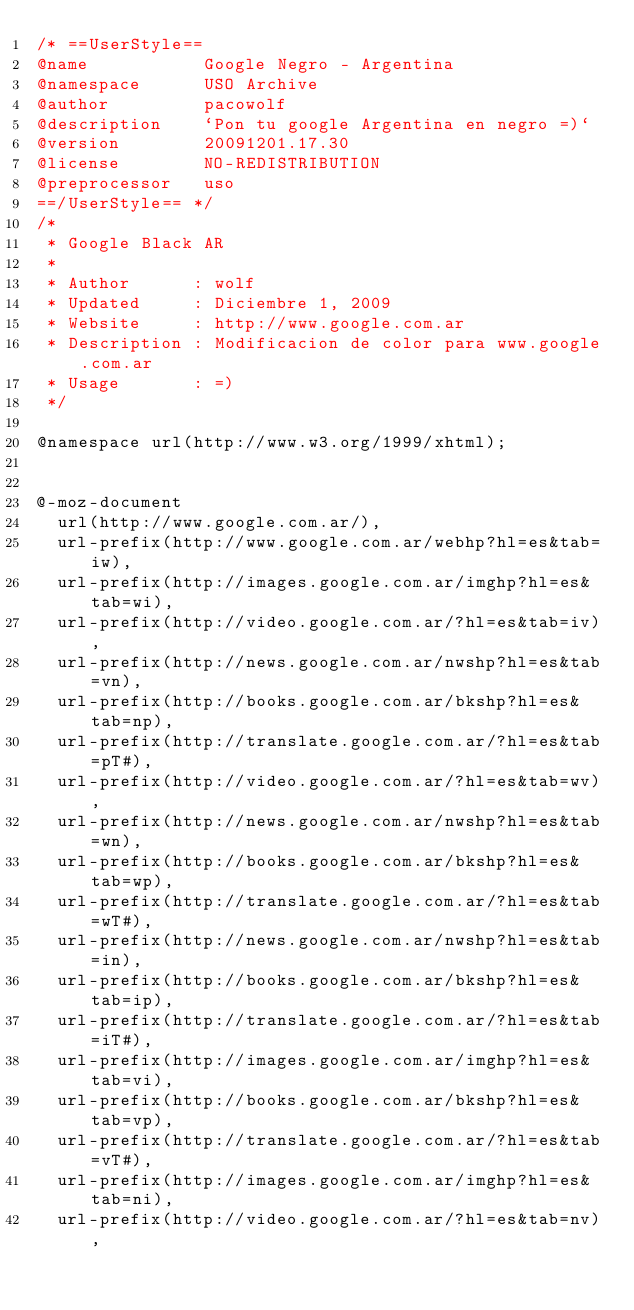Convert code to text. <code><loc_0><loc_0><loc_500><loc_500><_CSS_>/* ==UserStyle==
@name           Google Negro - Argentina
@namespace      USO Archive
@author         pacowolf
@description    `Pon tu google Argentina en negro =)`
@version        20091201.17.30
@license        NO-REDISTRIBUTION
@preprocessor   uso
==/UserStyle== */
/*
 * Google Black AR
 *
 * Author      : wolf
 * Updated     : Diciembre 1, 2009
 * Website     : http://www.google.com.ar
 * Description : Modificacion de color para www.google.com.ar 
 * Usage       : =)
 */

@namespace url(http://www.w3.org/1999/xhtml);


@-moz-document
  url(http://www.google.com.ar/),
  url-prefix(http://www.google.com.ar/webhp?hl=es&tab=iw),
  url-prefix(http://images.google.com.ar/imghp?hl=es&tab=wi),
  url-prefix(http://video.google.com.ar/?hl=es&tab=iv),
  url-prefix(http://news.google.com.ar/nwshp?hl=es&tab=vn),
  url-prefix(http://books.google.com.ar/bkshp?hl=es&tab=np),
  url-prefix(http://translate.google.com.ar/?hl=es&tab=pT#),
  url-prefix(http://video.google.com.ar/?hl=es&tab=wv),
  url-prefix(http://news.google.com.ar/nwshp?hl=es&tab=wn),
  url-prefix(http://books.google.com.ar/bkshp?hl=es&tab=wp),
  url-prefix(http://translate.google.com.ar/?hl=es&tab=wT#),
  url-prefix(http://news.google.com.ar/nwshp?hl=es&tab=in),
  url-prefix(http://books.google.com.ar/bkshp?hl=es&tab=ip),
  url-prefix(http://translate.google.com.ar/?hl=es&tab=iT#),
  url-prefix(http://images.google.com.ar/imghp?hl=es&tab=vi),
  url-prefix(http://books.google.com.ar/bkshp?hl=es&tab=vp),
  url-prefix(http://translate.google.com.ar/?hl=es&tab=vT#),
  url-prefix(http://images.google.com.ar/imghp?hl=es&tab=ni),
  url-prefix(http://video.google.com.ar/?hl=es&tab=nv),</code> 